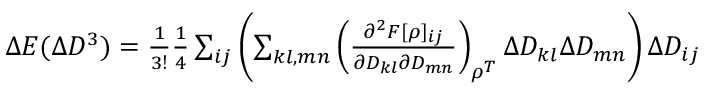Convert formula to latex. <formula><loc_0><loc_0><loc_500><loc_500>\begin{array} { r } { \Delta E ( \Delta D ^ { 3 } ) = \frac { 1 } { 3 ! } \frac { 1 } { 4 } \sum _ { i j } \left ( \sum _ { k l , m n } \left ( \frac { \partial ^ { 2 } F [ \rho ] _ { i j } } { \partial D _ { k l } \partial D _ { m n } } \right ) _ { \rho ^ { T } } \Delta D _ { k l } \Delta D _ { m n } \right ) \Delta D _ { i j } } \end{array}</formula> 